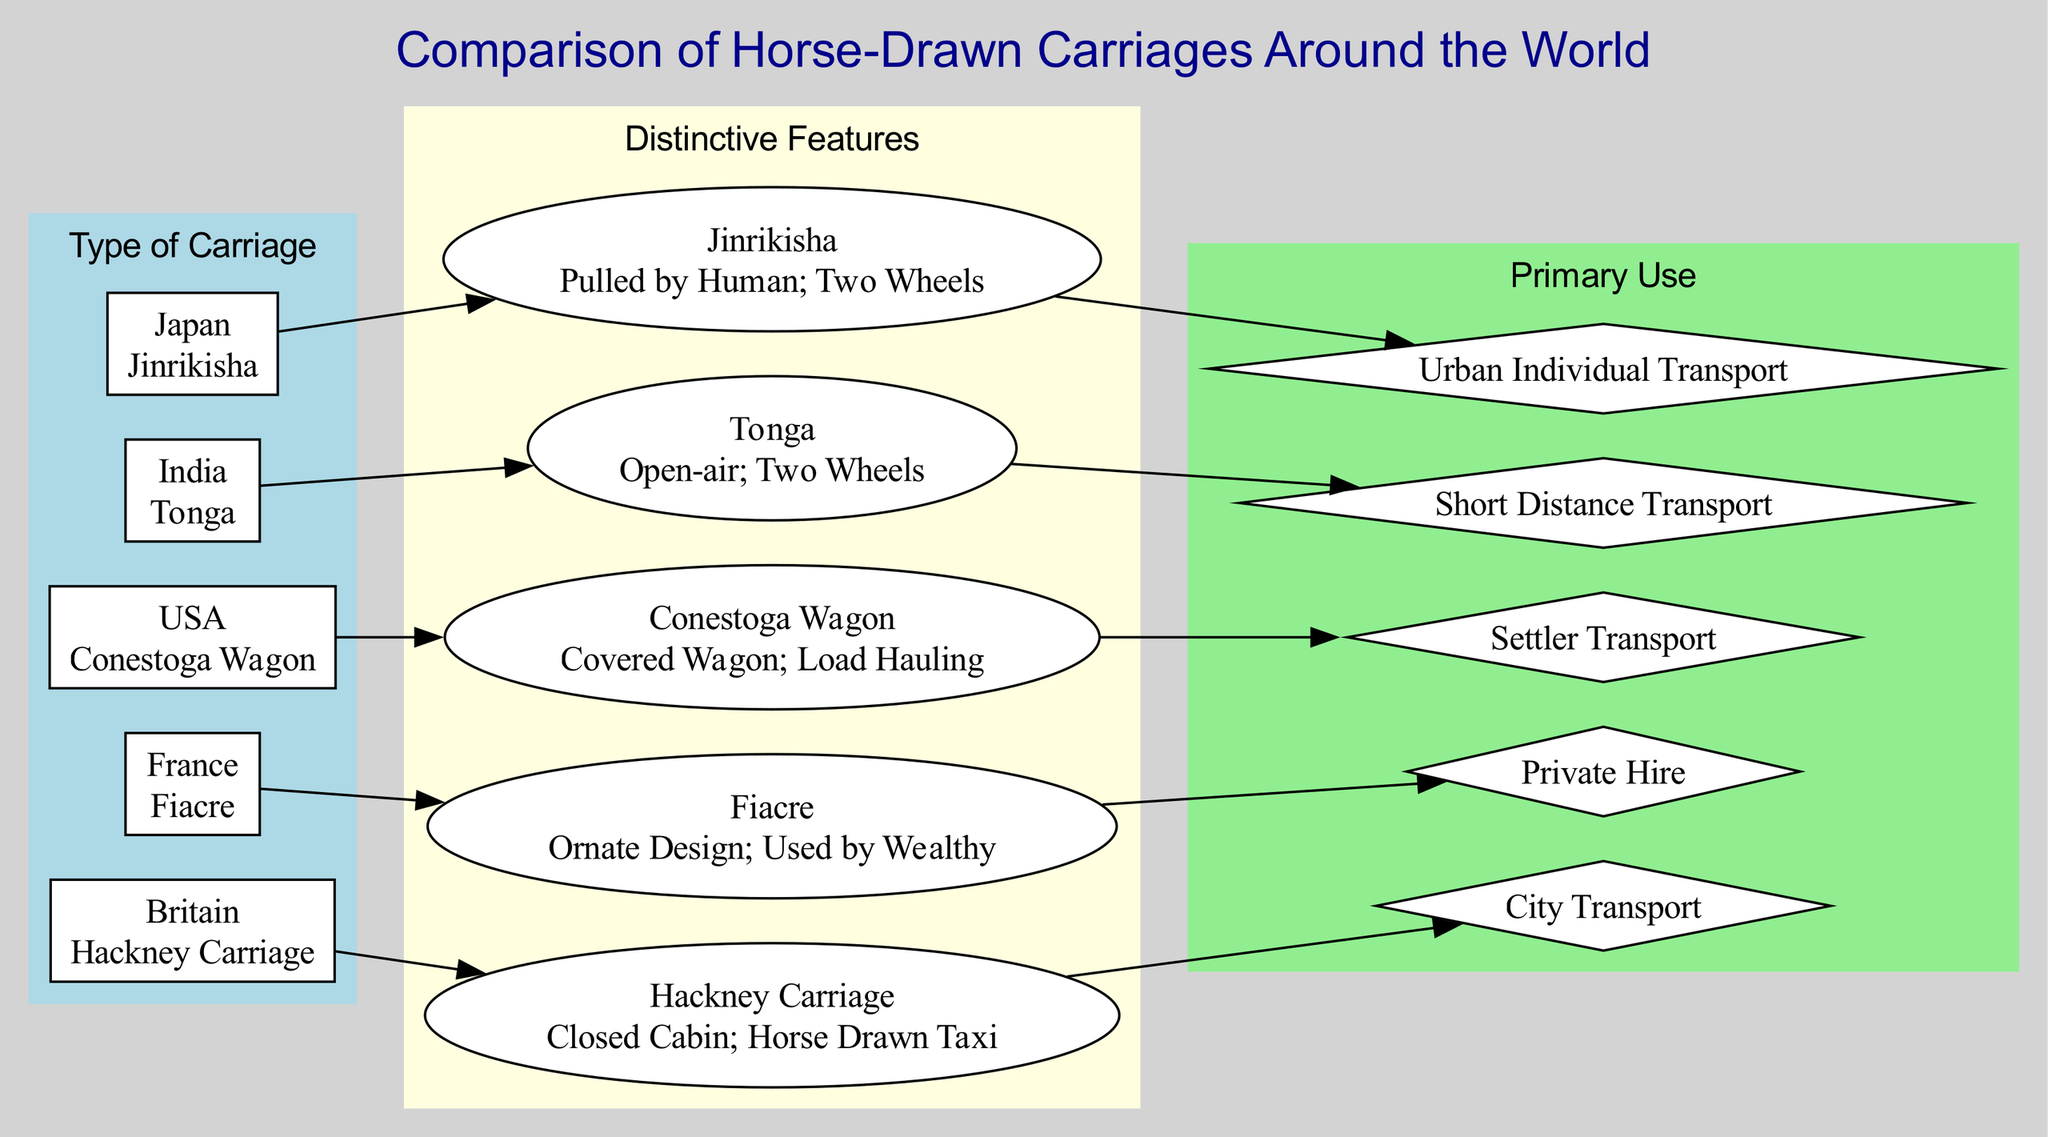What is the type of carriage associated with France? France is connected to the "Fiacre" in the "Type of Carriage" section of the diagram.
Answer: Fiacre How many types of carriages are listed in the diagram? The "Type of Carriage" category contains five elements: Hackney Carriage, Fiacre, Conestoga Wagon, Tonga, and Jinrikisha. Thus, the total number of types is five.
Answer: 5 What characteristic describes the Conestoga Wagon? The Conestoga Wagon is shown to have the characteristic "Covered Wagon; Load Hauling" in the "Distinctive Features" section.
Answer: Covered Wagon; Load Hauling What is the primary use of the Jinrikisha? In the "Primary Use" section, the Jinrikisha is designated for "Urban Individual Transport."
Answer: Urban Individual Transport Which carriage type is used by the wealthy? Looking at the "Distinctive Features," the Fiacre is indicated to be ornate and used by the wealthy.
Answer: Fiacre What relationship exists between the Hackney Carriage and its primary use? The diagram shows that the Hackney Carriage connects to "City Transport" in the "Primary Use" section, implying that it primarily serves this function.
Answer: City Transport Which type of carriage is primarily used for short-distance transport? The Tonga is specifically associated with "Short Distance Transport" in the "Primary Use" category, indicating its primary function.
Answer: Short Distance Transport Which carriages have an open-air design? The Tonga is identified with the characteristic "Open-air; Two Wheels," indicating it features an open design. The inquiry does not include other types as they are not mentioned as open.
Answer: Tonga What does the edge between the Hackney Carriage and Fiacre signify? The edge signifies that both carriage types have distinctive features and uses but are categorized differently under "Type of Carriage." Each serves a different cultural context.
Answer: Distinct carriages What distinctive feature links the two-wheeled characteristics? Both the Tonga and Jinrikisha are mentioned in their respective categories as having "Two Wheels," showing a commonality in their design despite differing uses.
Answer: Two Wheels 